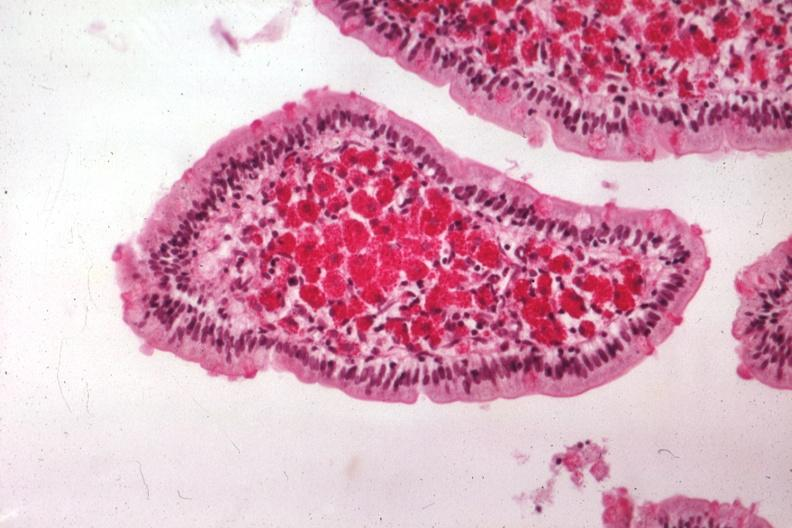what does this image show?
Answer the question using a single word or phrase. Med pas hematoxylin excellent demonstration source 